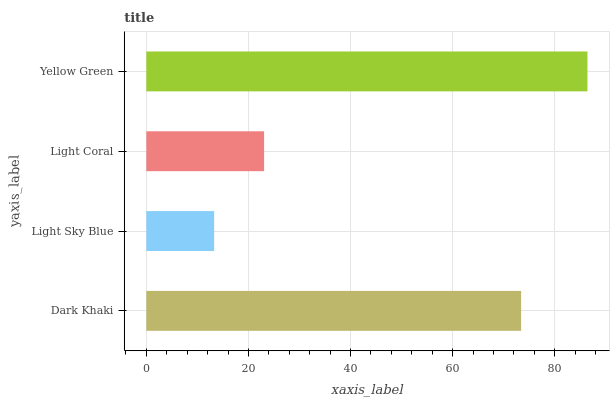Is Light Sky Blue the minimum?
Answer yes or no. Yes. Is Yellow Green the maximum?
Answer yes or no. Yes. Is Light Coral the minimum?
Answer yes or no. No. Is Light Coral the maximum?
Answer yes or no. No. Is Light Coral greater than Light Sky Blue?
Answer yes or no. Yes. Is Light Sky Blue less than Light Coral?
Answer yes or no. Yes. Is Light Sky Blue greater than Light Coral?
Answer yes or no. No. Is Light Coral less than Light Sky Blue?
Answer yes or no. No. Is Dark Khaki the high median?
Answer yes or no. Yes. Is Light Coral the low median?
Answer yes or no. Yes. Is Light Coral the high median?
Answer yes or no. No. Is Yellow Green the low median?
Answer yes or no. No. 